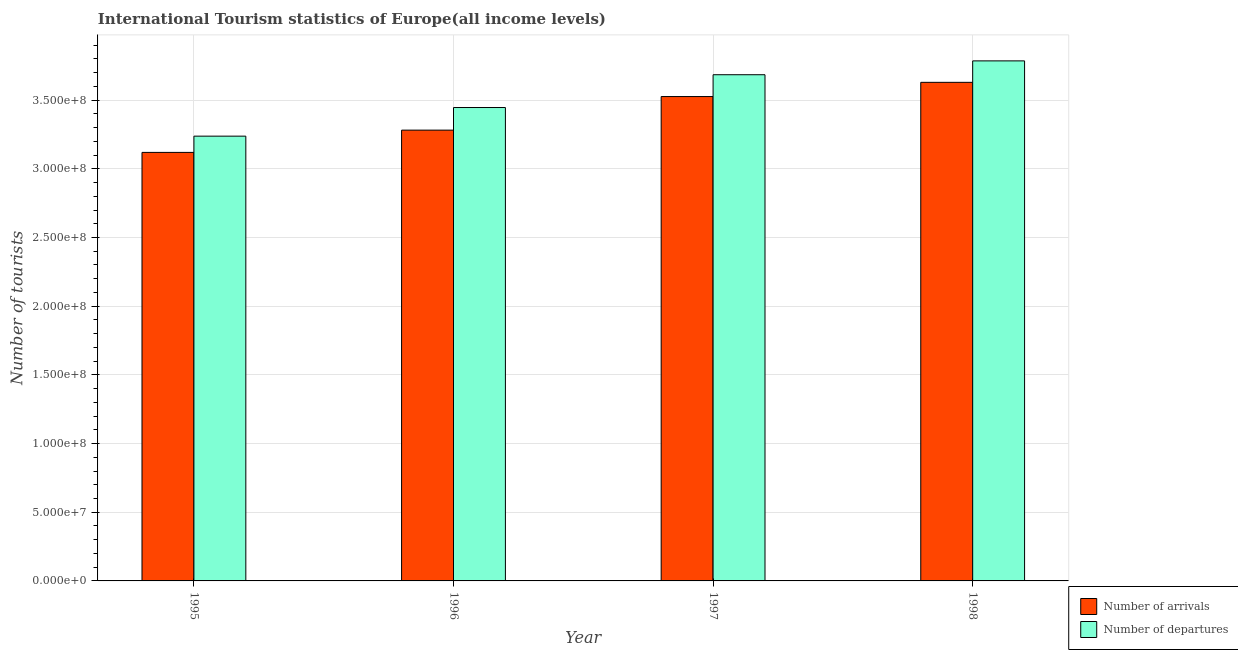How many groups of bars are there?
Offer a very short reply. 4. Are the number of bars per tick equal to the number of legend labels?
Ensure brevity in your answer.  Yes. How many bars are there on the 2nd tick from the right?
Your response must be concise. 2. What is the label of the 1st group of bars from the left?
Keep it short and to the point. 1995. In how many cases, is the number of bars for a given year not equal to the number of legend labels?
Provide a succinct answer. 0. What is the number of tourist arrivals in 1997?
Your response must be concise. 3.53e+08. Across all years, what is the maximum number of tourist arrivals?
Your answer should be very brief. 3.63e+08. Across all years, what is the minimum number of tourist departures?
Your answer should be very brief. 3.24e+08. In which year was the number of tourist departures minimum?
Provide a short and direct response. 1995. What is the total number of tourist departures in the graph?
Make the answer very short. 1.42e+09. What is the difference between the number of tourist departures in 1995 and that in 1998?
Provide a short and direct response. -5.48e+07. What is the difference between the number of tourist arrivals in 1997 and the number of tourist departures in 1998?
Your response must be concise. -1.03e+07. What is the average number of tourist departures per year?
Your answer should be compact. 3.54e+08. In how many years, is the number of tourist departures greater than 270000000?
Ensure brevity in your answer.  4. What is the ratio of the number of tourist departures in 1995 to that in 1998?
Your response must be concise. 0.86. Is the number of tourist departures in 1997 less than that in 1998?
Your response must be concise. Yes. What is the difference between the highest and the second highest number of tourist arrivals?
Offer a very short reply. 1.03e+07. What is the difference between the highest and the lowest number of tourist departures?
Keep it short and to the point. 5.48e+07. What does the 2nd bar from the left in 1995 represents?
Give a very brief answer. Number of departures. What does the 1st bar from the right in 1995 represents?
Offer a terse response. Number of departures. Are all the bars in the graph horizontal?
Offer a terse response. No. How many years are there in the graph?
Keep it short and to the point. 4. Where does the legend appear in the graph?
Offer a terse response. Bottom right. What is the title of the graph?
Keep it short and to the point. International Tourism statistics of Europe(all income levels). What is the label or title of the Y-axis?
Give a very brief answer. Number of tourists. What is the Number of tourists of Number of arrivals in 1995?
Your response must be concise. 3.12e+08. What is the Number of tourists of Number of departures in 1995?
Your answer should be compact. 3.24e+08. What is the Number of tourists of Number of arrivals in 1996?
Your answer should be very brief. 3.28e+08. What is the Number of tourists of Number of departures in 1996?
Provide a succinct answer. 3.45e+08. What is the Number of tourists in Number of arrivals in 1997?
Offer a very short reply. 3.53e+08. What is the Number of tourists in Number of departures in 1997?
Keep it short and to the point. 3.68e+08. What is the Number of tourists in Number of arrivals in 1998?
Provide a short and direct response. 3.63e+08. What is the Number of tourists of Number of departures in 1998?
Make the answer very short. 3.79e+08. Across all years, what is the maximum Number of tourists of Number of arrivals?
Provide a succinct answer. 3.63e+08. Across all years, what is the maximum Number of tourists of Number of departures?
Provide a succinct answer. 3.79e+08. Across all years, what is the minimum Number of tourists in Number of arrivals?
Offer a terse response. 3.12e+08. Across all years, what is the minimum Number of tourists in Number of departures?
Your response must be concise. 3.24e+08. What is the total Number of tourists of Number of arrivals in the graph?
Keep it short and to the point. 1.36e+09. What is the total Number of tourists in Number of departures in the graph?
Offer a terse response. 1.42e+09. What is the difference between the Number of tourists of Number of arrivals in 1995 and that in 1996?
Provide a short and direct response. -1.62e+07. What is the difference between the Number of tourists in Number of departures in 1995 and that in 1996?
Make the answer very short. -2.08e+07. What is the difference between the Number of tourists of Number of arrivals in 1995 and that in 1997?
Give a very brief answer. -4.06e+07. What is the difference between the Number of tourists in Number of departures in 1995 and that in 1997?
Provide a short and direct response. -4.47e+07. What is the difference between the Number of tourists in Number of arrivals in 1995 and that in 1998?
Provide a succinct answer. -5.10e+07. What is the difference between the Number of tourists of Number of departures in 1995 and that in 1998?
Your answer should be compact. -5.48e+07. What is the difference between the Number of tourists of Number of arrivals in 1996 and that in 1997?
Keep it short and to the point. -2.44e+07. What is the difference between the Number of tourists of Number of departures in 1996 and that in 1997?
Provide a short and direct response. -2.39e+07. What is the difference between the Number of tourists in Number of arrivals in 1996 and that in 1998?
Provide a succinct answer. -3.48e+07. What is the difference between the Number of tourists of Number of departures in 1996 and that in 1998?
Your answer should be compact. -3.40e+07. What is the difference between the Number of tourists of Number of arrivals in 1997 and that in 1998?
Your answer should be very brief. -1.03e+07. What is the difference between the Number of tourists in Number of departures in 1997 and that in 1998?
Your response must be concise. -1.01e+07. What is the difference between the Number of tourists in Number of arrivals in 1995 and the Number of tourists in Number of departures in 1996?
Keep it short and to the point. -3.27e+07. What is the difference between the Number of tourists in Number of arrivals in 1995 and the Number of tourists in Number of departures in 1997?
Keep it short and to the point. -5.65e+07. What is the difference between the Number of tourists of Number of arrivals in 1995 and the Number of tourists of Number of departures in 1998?
Offer a terse response. -6.66e+07. What is the difference between the Number of tourists in Number of arrivals in 1996 and the Number of tourists in Number of departures in 1997?
Ensure brevity in your answer.  -4.03e+07. What is the difference between the Number of tourists in Number of arrivals in 1996 and the Number of tourists in Number of departures in 1998?
Make the answer very short. -5.04e+07. What is the difference between the Number of tourists in Number of arrivals in 1997 and the Number of tourists in Number of departures in 1998?
Your response must be concise. -2.60e+07. What is the average Number of tourists of Number of arrivals per year?
Ensure brevity in your answer.  3.39e+08. What is the average Number of tourists of Number of departures per year?
Make the answer very short. 3.54e+08. In the year 1995, what is the difference between the Number of tourists of Number of arrivals and Number of tourists of Number of departures?
Give a very brief answer. -1.18e+07. In the year 1996, what is the difference between the Number of tourists in Number of arrivals and Number of tourists in Number of departures?
Keep it short and to the point. -1.65e+07. In the year 1997, what is the difference between the Number of tourists of Number of arrivals and Number of tourists of Number of departures?
Give a very brief answer. -1.59e+07. In the year 1998, what is the difference between the Number of tourists of Number of arrivals and Number of tourists of Number of departures?
Your response must be concise. -1.56e+07. What is the ratio of the Number of tourists in Number of arrivals in 1995 to that in 1996?
Keep it short and to the point. 0.95. What is the ratio of the Number of tourists of Number of departures in 1995 to that in 1996?
Offer a very short reply. 0.94. What is the ratio of the Number of tourists in Number of arrivals in 1995 to that in 1997?
Your answer should be very brief. 0.88. What is the ratio of the Number of tourists in Number of departures in 1995 to that in 1997?
Give a very brief answer. 0.88. What is the ratio of the Number of tourists in Number of arrivals in 1995 to that in 1998?
Provide a short and direct response. 0.86. What is the ratio of the Number of tourists in Number of departures in 1995 to that in 1998?
Offer a very short reply. 0.86. What is the ratio of the Number of tourists of Number of arrivals in 1996 to that in 1997?
Give a very brief answer. 0.93. What is the ratio of the Number of tourists in Number of departures in 1996 to that in 1997?
Ensure brevity in your answer.  0.94. What is the ratio of the Number of tourists of Number of arrivals in 1996 to that in 1998?
Provide a short and direct response. 0.9. What is the ratio of the Number of tourists of Number of departures in 1996 to that in 1998?
Offer a terse response. 0.91. What is the ratio of the Number of tourists of Number of arrivals in 1997 to that in 1998?
Ensure brevity in your answer.  0.97. What is the ratio of the Number of tourists of Number of departures in 1997 to that in 1998?
Provide a succinct answer. 0.97. What is the difference between the highest and the second highest Number of tourists in Number of arrivals?
Your answer should be compact. 1.03e+07. What is the difference between the highest and the second highest Number of tourists in Number of departures?
Offer a very short reply. 1.01e+07. What is the difference between the highest and the lowest Number of tourists in Number of arrivals?
Keep it short and to the point. 5.10e+07. What is the difference between the highest and the lowest Number of tourists in Number of departures?
Make the answer very short. 5.48e+07. 